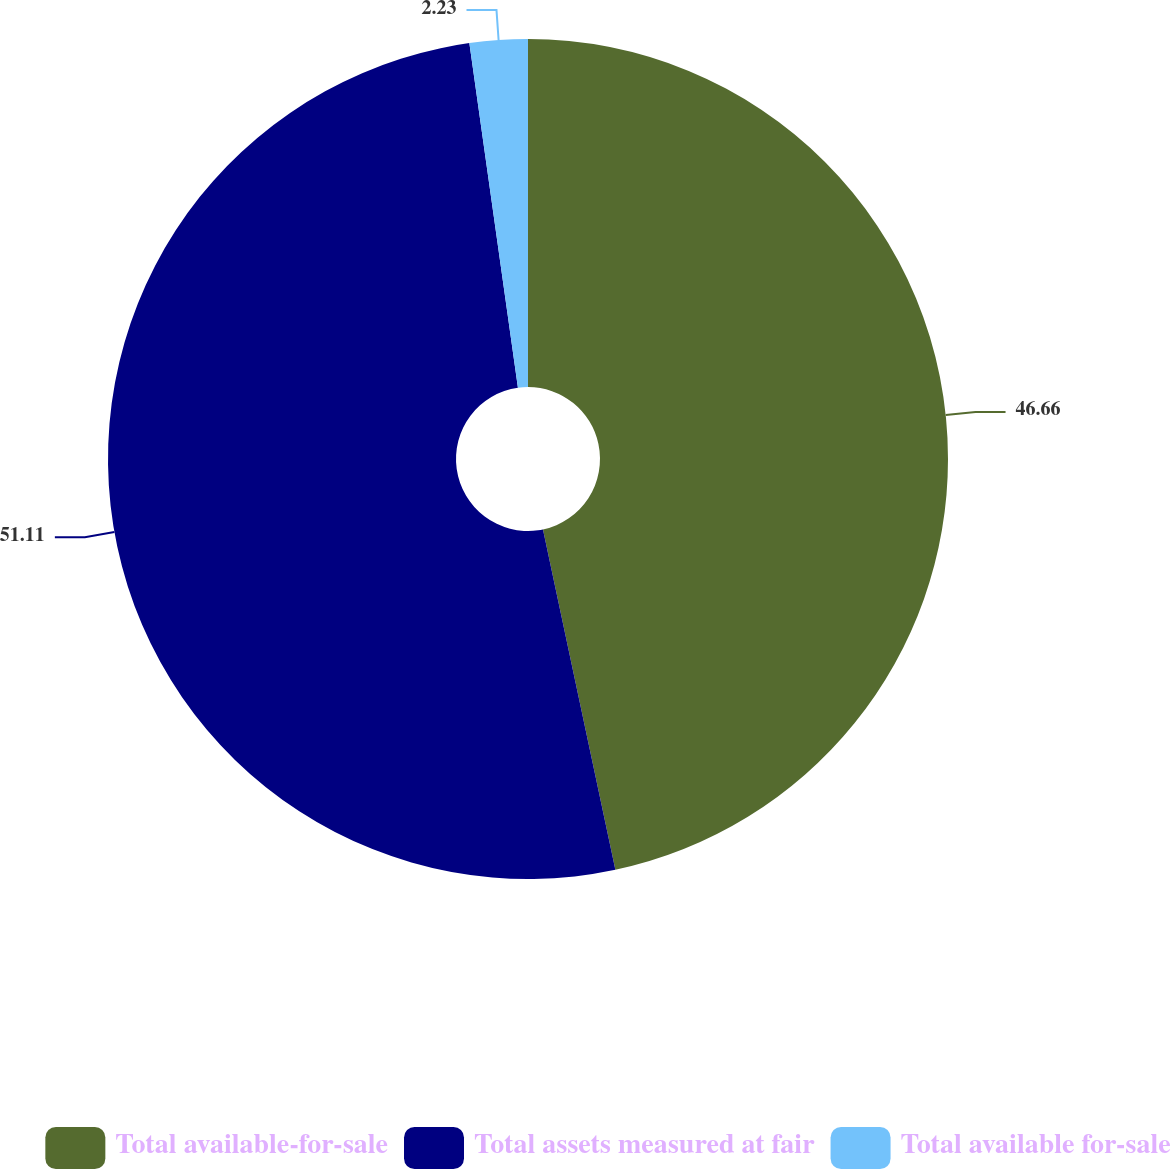<chart> <loc_0><loc_0><loc_500><loc_500><pie_chart><fcel>Total available-for-sale<fcel>Total assets measured at fair<fcel>Total available for-sale<nl><fcel>46.66%<fcel>51.1%<fcel>2.23%<nl></chart> 